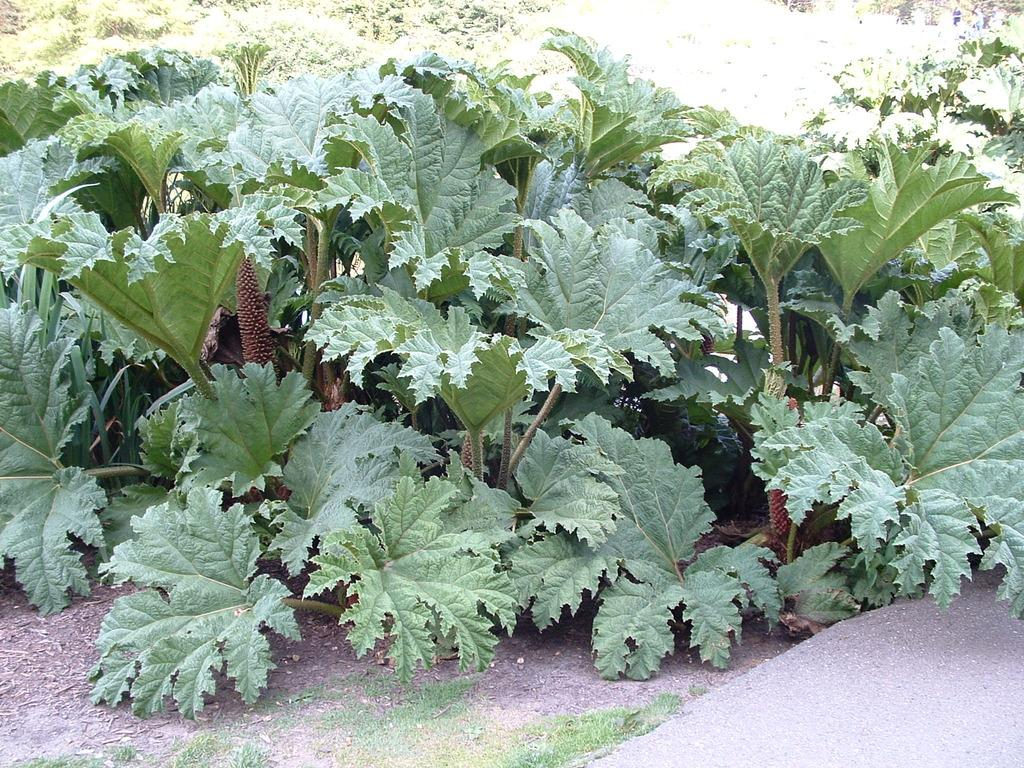What type of vegetation can be seen in the image? There are trees in the image. What type of ground surface is visible in the image? There is soil visible on the bottom right side of the image. What type of vacation is being taken in the image? There is no indication of a vacation in the image; it simply features trees and soil. What is the height of the trees in the image? The height of the trees cannot be determined from the image alone. What is being served for breakfast in the image? There is no reference to breakfast or any food items in the image. 